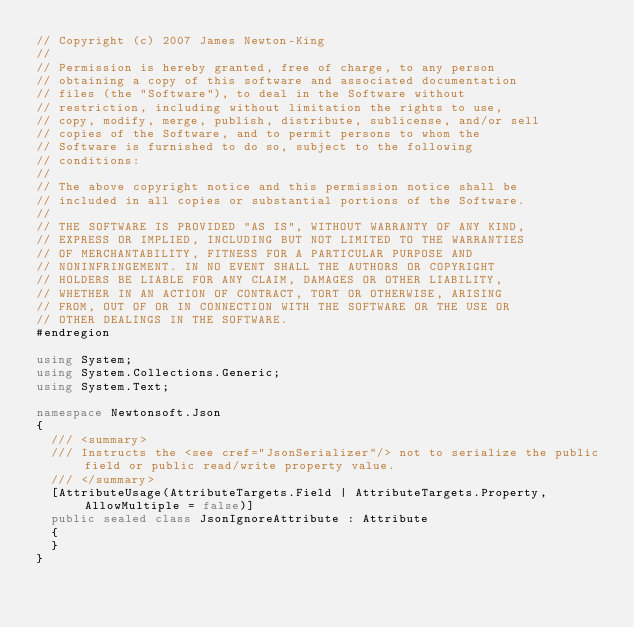<code> <loc_0><loc_0><loc_500><loc_500><_C#_>// Copyright (c) 2007 James Newton-King
//
// Permission is hereby granted, free of charge, to any person
// obtaining a copy of this software and associated documentation
// files (the "Software"), to deal in the Software without
// restriction, including without limitation the rights to use,
// copy, modify, merge, publish, distribute, sublicense, and/or sell
// copies of the Software, and to permit persons to whom the
// Software is furnished to do so, subject to the following
// conditions:
//
// The above copyright notice and this permission notice shall be
// included in all copies or substantial portions of the Software.
//
// THE SOFTWARE IS PROVIDED "AS IS", WITHOUT WARRANTY OF ANY KIND,
// EXPRESS OR IMPLIED, INCLUDING BUT NOT LIMITED TO THE WARRANTIES
// OF MERCHANTABILITY, FITNESS FOR A PARTICULAR PURPOSE AND
// NONINFRINGEMENT. IN NO EVENT SHALL THE AUTHORS OR COPYRIGHT
// HOLDERS BE LIABLE FOR ANY CLAIM, DAMAGES OR OTHER LIABILITY,
// WHETHER IN AN ACTION OF CONTRACT, TORT OR OTHERWISE, ARISING
// FROM, OUT OF OR IN CONNECTION WITH THE SOFTWARE OR THE USE OR
// OTHER DEALINGS IN THE SOFTWARE.
#endregion

using System;
using System.Collections.Generic;
using System.Text;

namespace Newtonsoft.Json
{
  /// <summary>
  /// Instructs the <see cref="JsonSerializer"/> not to serialize the public field or public read/write property value.
  /// </summary>
  [AttributeUsage(AttributeTargets.Field | AttributeTargets.Property, AllowMultiple = false)]
  public sealed class JsonIgnoreAttribute : Attribute
  {
  }
}</code> 